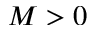Convert formula to latex. <formula><loc_0><loc_0><loc_500><loc_500>M > 0</formula> 